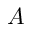<formula> <loc_0><loc_0><loc_500><loc_500>A</formula> 